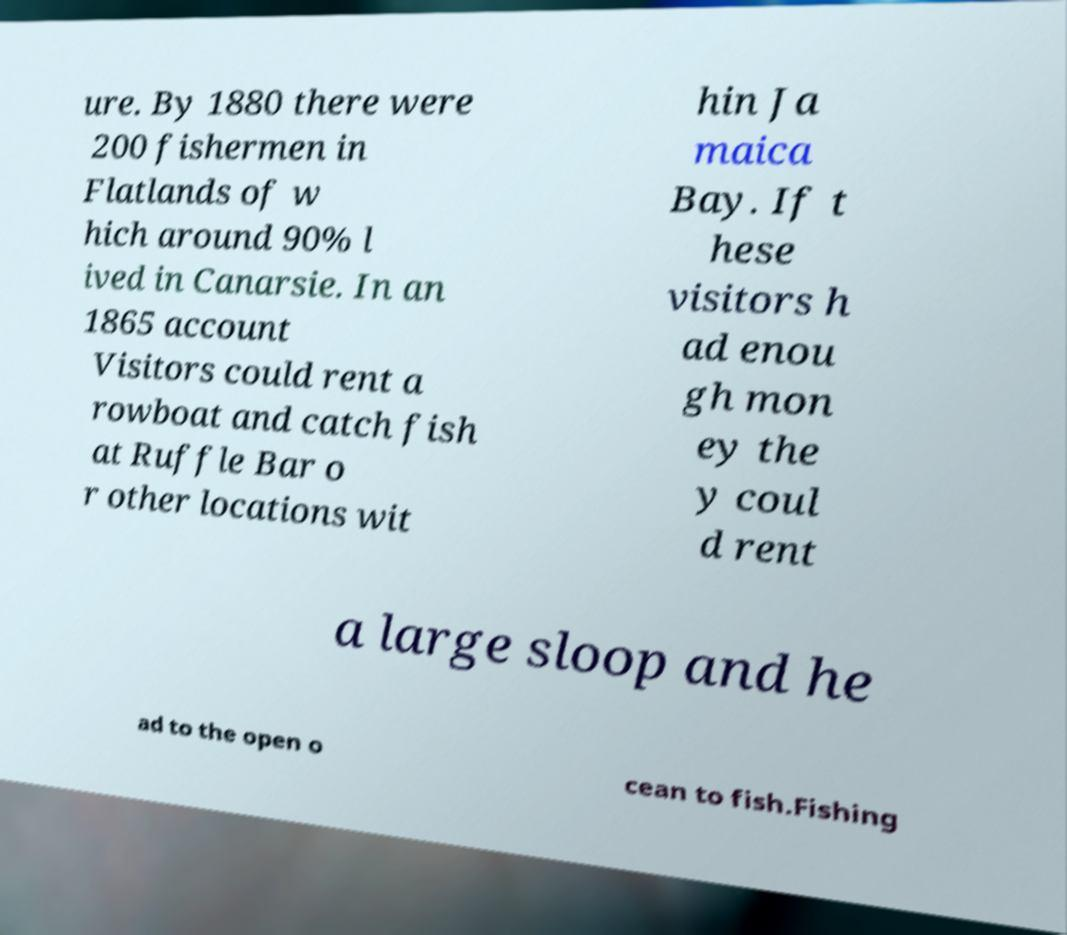For documentation purposes, I need the text within this image transcribed. Could you provide that? ure. By 1880 there were 200 fishermen in Flatlands of w hich around 90% l ived in Canarsie. In an 1865 account Visitors could rent a rowboat and catch fish at Ruffle Bar o r other locations wit hin Ja maica Bay. If t hese visitors h ad enou gh mon ey the y coul d rent a large sloop and he ad to the open o cean to fish.Fishing 